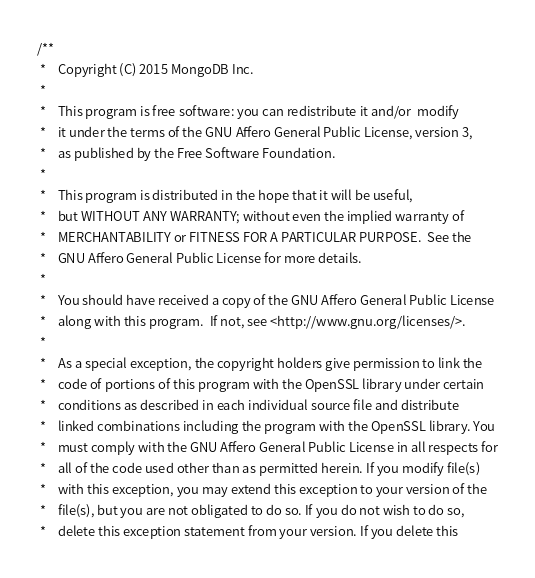Convert code to text. <code><loc_0><loc_0><loc_500><loc_500><_C_>/**
 *    Copyright (C) 2015 MongoDB Inc.
 *
 *    This program is free software: you can redistribute it and/or  modify
 *    it under the terms of the GNU Affero General Public License, version 3,
 *    as published by the Free Software Foundation.
 *
 *    This program is distributed in the hope that it will be useful,
 *    but WITHOUT ANY WARRANTY; without even the implied warranty of
 *    MERCHANTABILITY or FITNESS FOR A PARTICULAR PURPOSE.  See the
 *    GNU Affero General Public License for more details.
 *
 *    You should have received a copy of the GNU Affero General Public License
 *    along with this program.  If not, see <http://www.gnu.org/licenses/>.
 *
 *    As a special exception, the copyright holders give permission to link the
 *    code of portions of this program with the OpenSSL library under certain
 *    conditions as described in each individual source file and distribute
 *    linked combinations including the program with the OpenSSL library. You
 *    must comply with the GNU Affero General Public License in all respects for
 *    all of the code used other than as permitted herein. If you modify file(s)
 *    with this exception, you may extend this exception to your version of the
 *    file(s), but you are not obligated to do so. If you do not wish to do so,
 *    delete this exception statement from your version. If you delete this</code> 